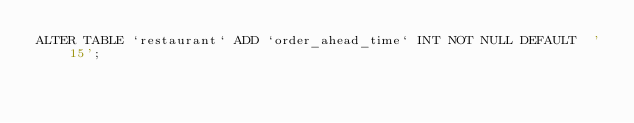Convert code to text. <code><loc_0><loc_0><loc_500><loc_500><_SQL_>ALTER TABLE `restaurant` ADD `order_ahead_time` INT NOT NULL DEFAULT  '15';</code> 